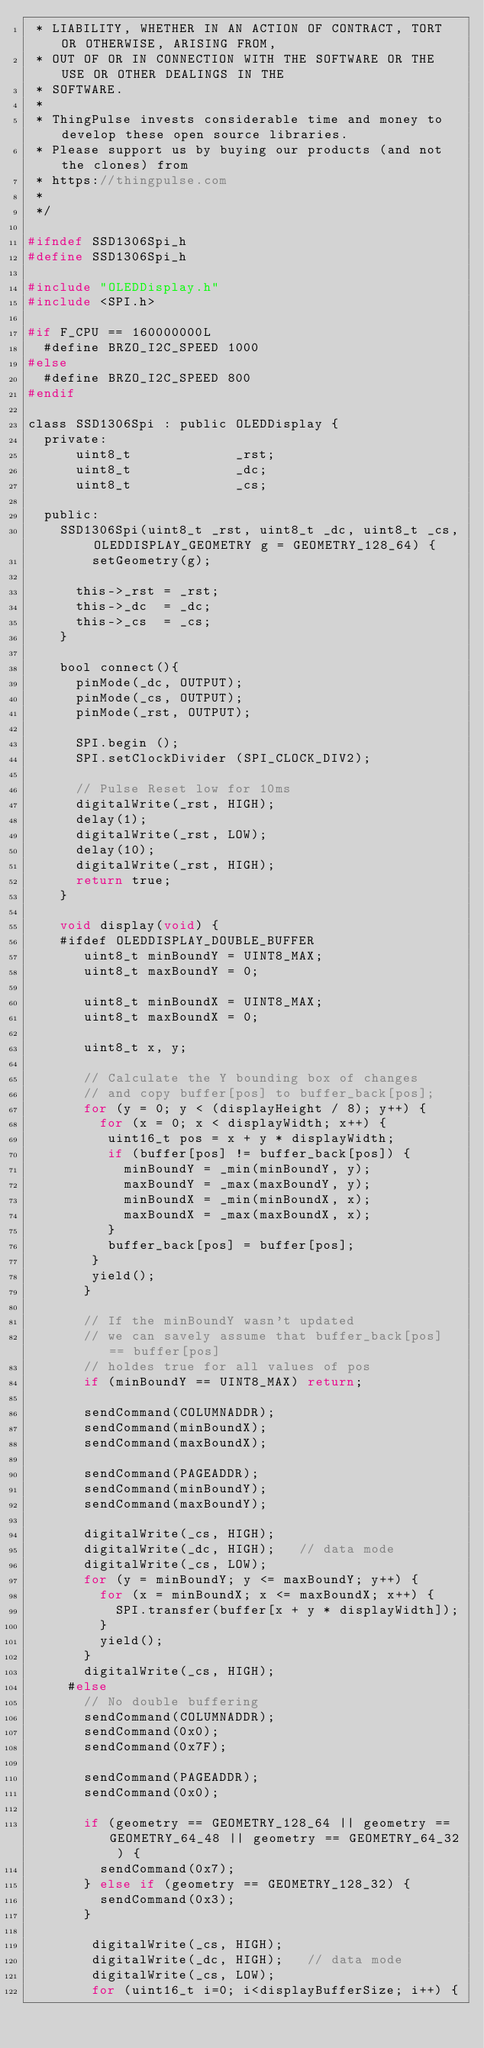<code> <loc_0><loc_0><loc_500><loc_500><_C_> * LIABILITY, WHETHER IN AN ACTION OF CONTRACT, TORT OR OTHERWISE, ARISING FROM,
 * OUT OF OR IN CONNECTION WITH THE SOFTWARE OR THE USE OR OTHER DEALINGS IN THE
 * SOFTWARE.
 *
 * ThingPulse invests considerable time and money to develop these open source libraries.
 * Please support us by buying our products (and not the clones) from
 * https://thingpulse.com
 *
 */

#ifndef SSD1306Spi_h
#define SSD1306Spi_h

#include "OLEDDisplay.h"
#include <SPI.h>

#if F_CPU == 160000000L
  #define BRZO_I2C_SPEED 1000
#else
  #define BRZO_I2C_SPEED 800
#endif

class SSD1306Spi : public OLEDDisplay {
  private:
      uint8_t             _rst;
      uint8_t             _dc;
      uint8_t             _cs;

  public:
    SSD1306Spi(uint8_t _rst, uint8_t _dc, uint8_t _cs, OLEDDISPLAY_GEOMETRY g = GEOMETRY_128_64) {
        setGeometry(g);

      this->_rst = _rst;
      this->_dc  = _dc;
      this->_cs  = _cs;
    }

    bool connect(){
      pinMode(_dc, OUTPUT);
      pinMode(_cs, OUTPUT);
      pinMode(_rst, OUTPUT);

      SPI.begin ();
      SPI.setClockDivider (SPI_CLOCK_DIV2);

      // Pulse Reset low for 10ms
      digitalWrite(_rst, HIGH);
      delay(1);
      digitalWrite(_rst, LOW);
      delay(10);
      digitalWrite(_rst, HIGH);
      return true;
    }

    void display(void) {
    #ifdef OLEDDISPLAY_DOUBLE_BUFFER
       uint8_t minBoundY = UINT8_MAX;
       uint8_t maxBoundY = 0;

       uint8_t minBoundX = UINT8_MAX;
       uint8_t maxBoundX = 0;

       uint8_t x, y;

       // Calculate the Y bounding box of changes
       // and copy buffer[pos] to buffer_back[pos];
       for (y = 0; y < (displayHeight / 8); y++) {
         for (x = 0; x < displayWidth; x++) {
          uint16_t pos = x + y * displayWidth;
          if (buffer[pos] != buffer_back[pos]) {
            minBoundY = _min(minBoundY, y);
            maxBoundY = _max(maxBoundY, y);
            minBoundX = _min(minBoundX, x);
            maxBoundX = _max(maxBoundX, x);
          }
          buffer_back[pos] = buffer[pos];
        }
        yield();
       }

       // If the minBoundY wasn't updated
       // we can savely assume that buffer_back[pos] == buffer[pos]
       // holdes true for all values of pos
       if (minBoundY == UINT8_MAX) return;

       sendCommand(COLUMNADDR);
       sendCommand(minBoundX);
       sendCommand(maxBoundX);

       sendCommand(PAGEADDR);
       sendCommand(minBoundY);
       sendCommand(maxBoundY);

       digitalWrite(_cs, HIGH);
       digitalWrite(_dc, HIGH);   // data mode
       digitalWrite(_cs, LOW);
       for (y = minBoundY; y <= maxBoundY; y++) {
         for (x = minBoundX; x <= maxBoundX; x++) {
           SPI.transfer(buffer[x + y * displayWidth]);
         }
         yield();
       }
       digitalWrite(_cs, HIGH);
     #else
       // No double buffering
       sendCommand(COLUMNADDR);
       sendCommand(0x0);
       sendCommand(0x7F);

       sendCommand(PAGEADDR);
       sendCommand(0x0);

       if (geometry == GEOMETRY_128_64 || geometry == GEOMETRY_64_48 || geometry == GEOMETRY_64_32 ) {
         sendCommand(0x7);
       } else if (geometry == GEOMETRY_128_32) {
         sendCommand(0x3);
       }

        digitalWrite(_cs, HIGH);
        digitalWrite(_dc, HIGH);   // data mode
        digitalWrite(_cs, LOW);
        for (uint16_t i=0; i<displayBufferSize; i++) {</code> 